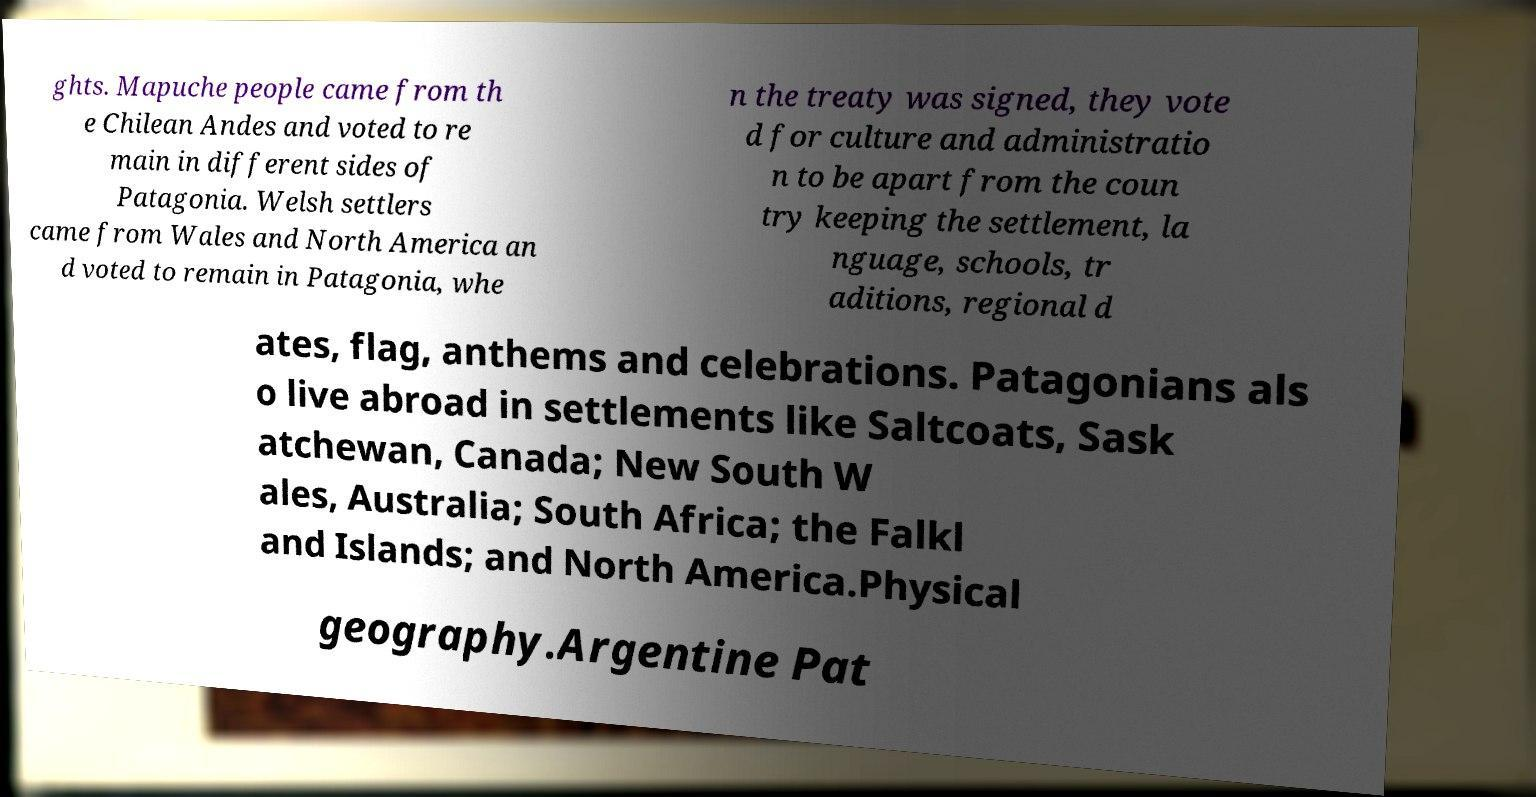Can you accurately transcribe the text from the provided image for me? ghts. Mapuche people came from th e Chilean Andes and voted to re main in different sides of Patagonia. Welsh settlers came from Wales and North America an d voted to remain in Patagonia, whe n the treaty was signed, they vote d for culture and administratio n to be apart from the coun try keeping the settlement, la nguage, schools, tr aditions, regional d ates, flag, anthems and celebrations. Patagonians als o live abroad in settlements like Saltcoats, Sask atchewan, Canada; New South W ales, Australia; South Africa; the Falkl and Islands; and North America.Physical geography.Argentine Pat 